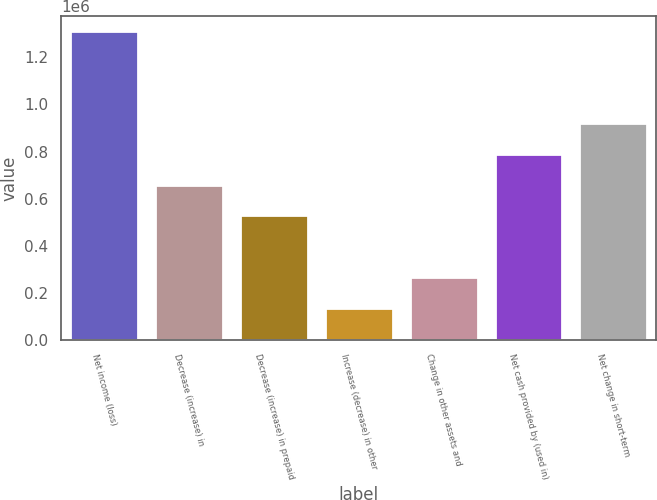<chart> <loc_0><loc_0><loc_500><loc_500><bar_chart><fcel>Net income (loss)<fcel>Decrease (increase) in<fcel>Decrease (increase) in prepaid<fcel>Increase (decrease) in other<fcel>Change in other assets and<fcel>Net cash provided by (used in)<fcel>Net change in short-term<nl><fcel>1.311e+06<fcel>659198<fcel>528273<fcel>135500<fcel>266424<fcel>790123<fcel>921047<nl></chart> 